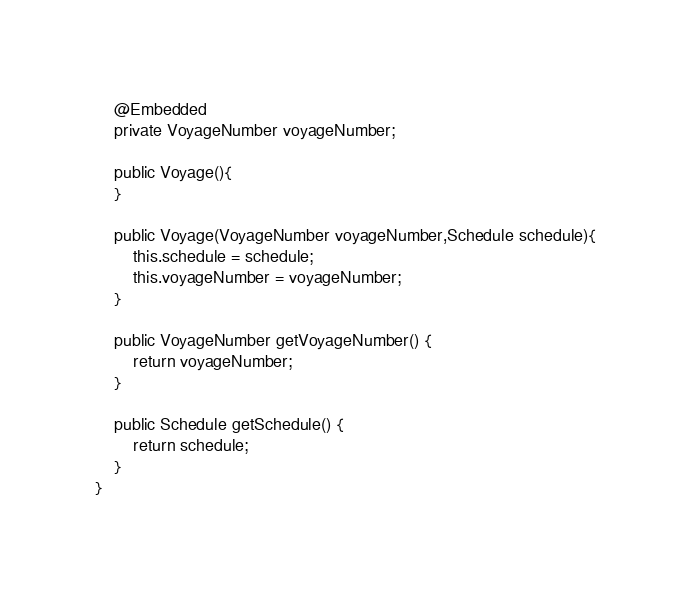Convert code to text. <code><loc_0><loc_0><loc_500><loc_500><_Java_>    @Embedded
    private VoyageNumber voyageNumber;

    public Voyage(){
    }

    public Voyage(VoyageNumber voyageNumber,Schedule schedule){
        this.schedule = schedule;
        this.voyageNumber = voyageNumber;
    }

    public VoyageNumber getVoyageNumber() {
        return voyageNumber;
    }

    public Schedule getSchedule() {
        return schedule;
    }
}</code> 